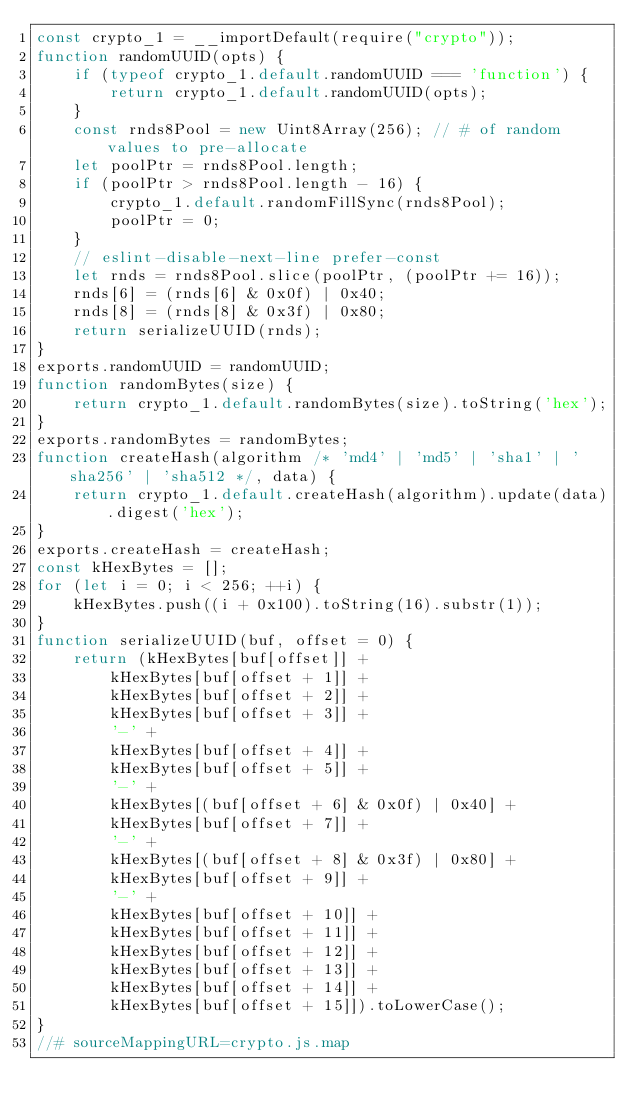<code> <loc_0><loc_0><loc_500><loc_500><_JavaScript_>const crypto_1 = __importDefault(require("crypto"));
function randomUUID(opts) {
    if (typeof crypto_1.default.randomUUID === 'function') {
        return crypto_1.default.randomUUID(opts);
    }
    const rnds8Pool = new Uint8Array(256); // # of random values to pre-allocate
    let poolPtr = rnds8Pool.length;
    if (poolPtr > rnds8Pool.length - 16) {
        crypto_1.default.randomFillSync(rnds8Pool);
        poolPtr = 0;
    }
    // eslint-disable-next-line prefer-const
    let rnds = rnds8Pool.slice(poolPtr, (poolPtr += 16));
    rnds[6] = (rnds[6] & 0x0f) | 0x40;
    rnds[8] = (rnds[8] & 0x3f) | 0x80;
    return serializeUUID(rnds);
}
exports.randomUUID = randomUUID;
function randomBytes(size) {
    return crypto_1.default.randomBytes(size).toString('hex');
}
exports.randomBytes = randomBytes;
function createHash(algorithm /* 'md4' | 'md5' | 'sha1' | 'sha256' | 'sha512 */, data) {
    return crypto_1.default.createHash(algorithm).update(data).digest('hex');
}
exports.createHash = createHash;
const kHexBytes = [];
for (let i = 0; i < 256; ++i) {
    kHexBytes.push((i + 0x100).toString(16).substr(1));
}
function serializeUUID(buf, offset = 0) {
    return (kHexBytes[buf[offset]] +
        kHexBytes[buf[offset + 1]] +
        kHexBytes[buf[offset + 2]] +
        kHexBytes[buf[offset + 3]] +
        '-' +
        kHexBytes[buf[offset + 4]] +
        kHexBytes[buf[offset + 5]] +
        '-' +
        kHexBytes[(buf[offset + 6] & 0x0f) | 0x40] +
        kHexBytes[buf[offset + 7]] +
        '-' +
        kHexBytes[(buf[offset + 8] & 0x3f) | 0x80] +
        kHexBytes[buf[offset + 9]] +
        '-' +
        kHexBytes[buf[offset + 10]] +
        kHexBytes[buf[offset + 11]] +
        kHexBytes[buf[offset + 12]] +
        kHexBytes[buf[offset + 13]] +
        kHexBytes[buf[offset + 14]] +
        kHexBytes[buf[offset + 15]]).toLowerCase();
}
//# sourceMappingURL=crypto.js.map</code> 